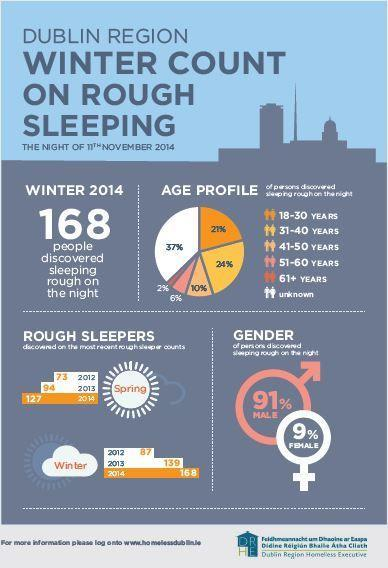How many rough sleepers were discovered in the spring season of 2012?
Answer the question with a short phrase. 73 What percentage of people in the age group of 31-40 years were sleeping rough on the night of 11th November 2014 in Dublin region? 24% What percentage of males were sleeping rough on the night of 11th November 2014 in Dublin region? 91% How many rough sleepers were discovered in the spring season of 2014? 127 What percentage of females were sleeping rough on the night of 11th November 2014 in Dublin region? 9% What percentage of people in the age group of 51-60 years were sleeping rough on the night of 11th November 2014 in Dublin region? 6% What percentage of people in the age group of 18-30 years were sleeping rough on the night of 11th November 2014 in Dublin region? 21% How many rough sleepers were discovered in the winter season of 2014? 168 